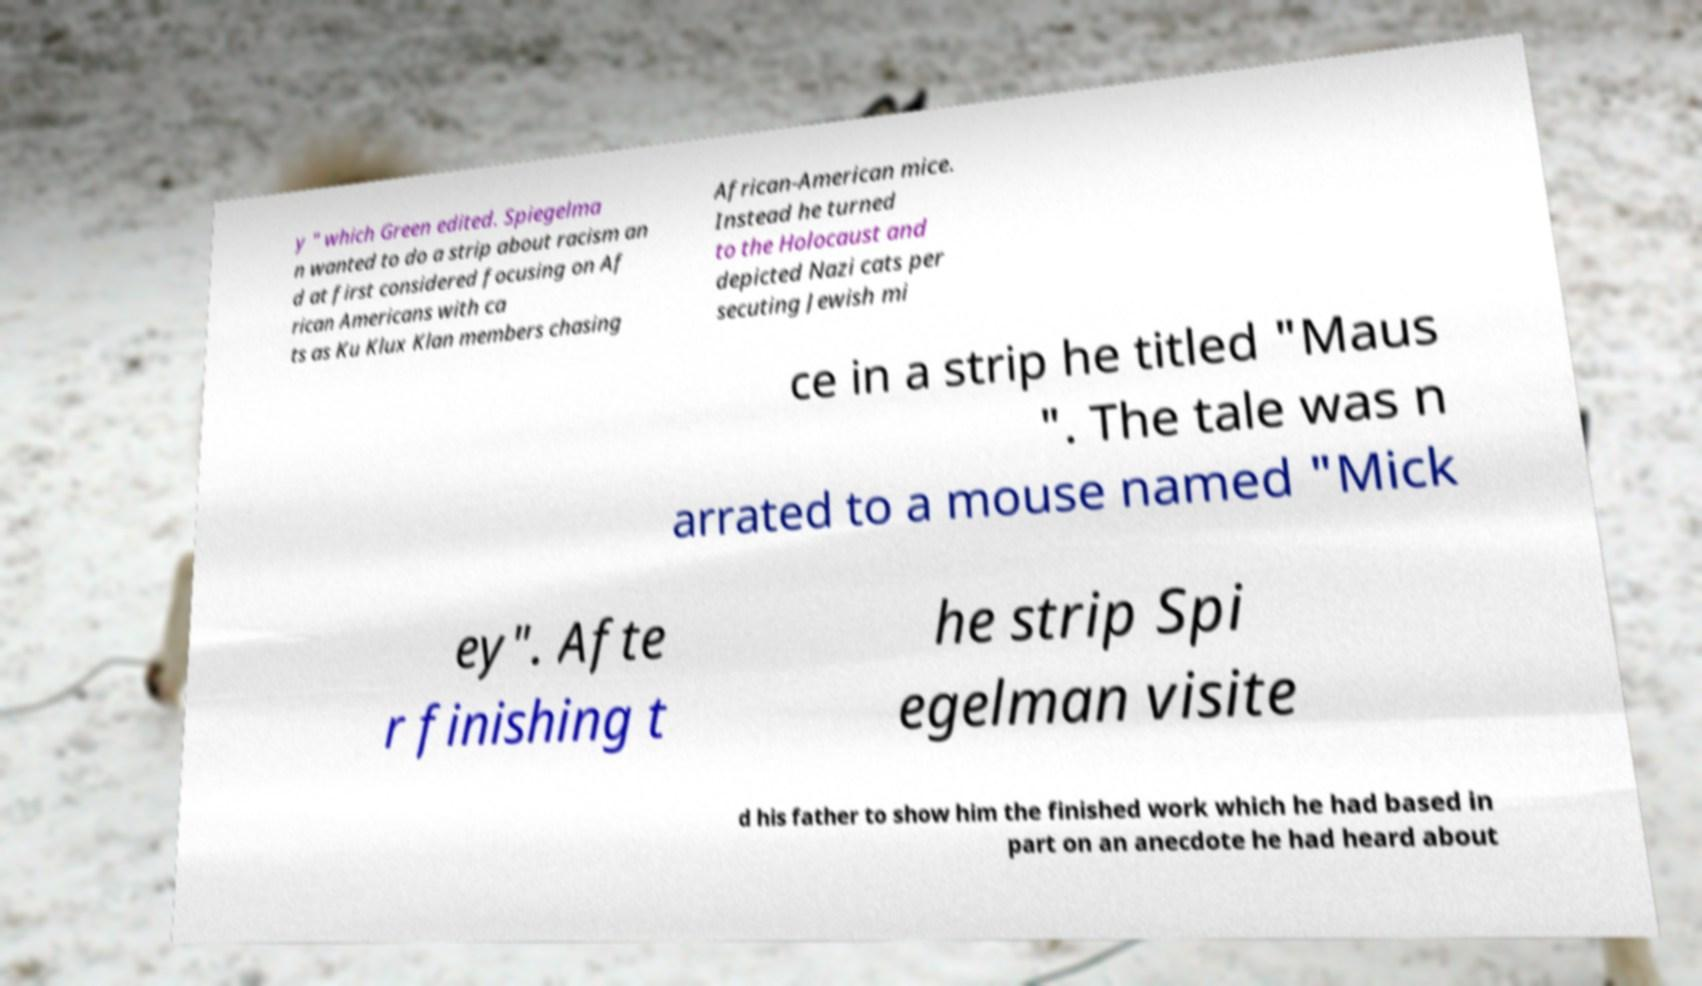For documentation purposes, I need the text within this image transcribed. Could you provide that? y " which Green edited. Spiegelma n wanted to do a strip about racism an d at first considered focusing on Af rican Americans with ca ts as Ku Klux Klan members chasing African-American mice. Instead he turned to the Holocaust and depicted Nazi cats per secuting Jewish mi ce in a strip he titled "Maus ". The tale was n arrated to a mouse named "Mick ey". Afte r finishing t he strip Spi egelman visite d his father to show him the finished work which he had based in part on an anecdote he had heard about 